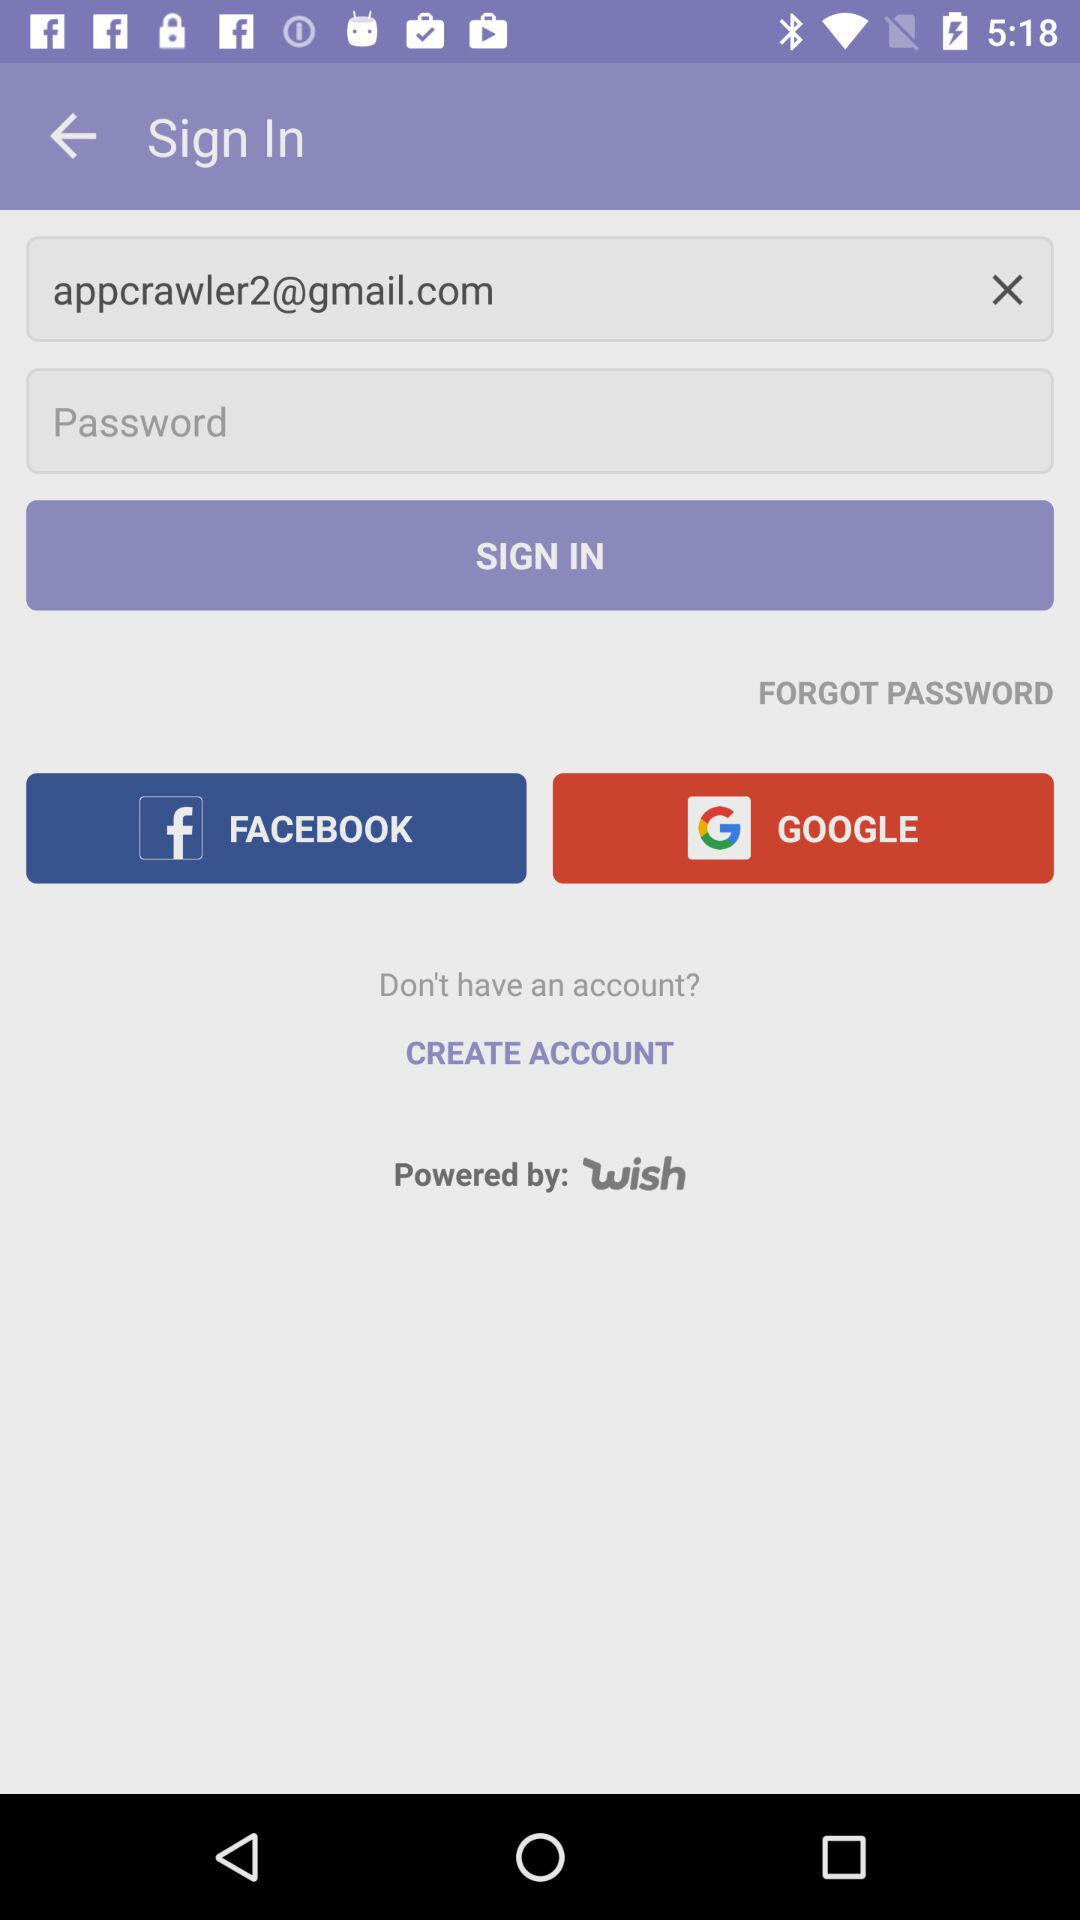What is the sign-in email? The email address is appcrawler2@gmail.com. 